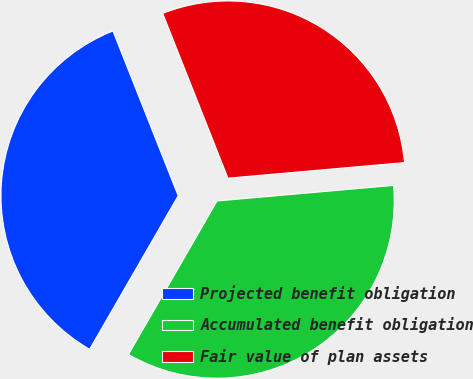Convert chart to OTSL. <chart><loc_0><loc_0><loc_500><loc_500><pie_chart><fcel>Projected benefit obligation<fcel>Accumulated benefit obligation<fcel>Fair value of plan assets<nl><fcel>35.67%<fcel>34.73%<fcel>29.6%<nl></chart> 